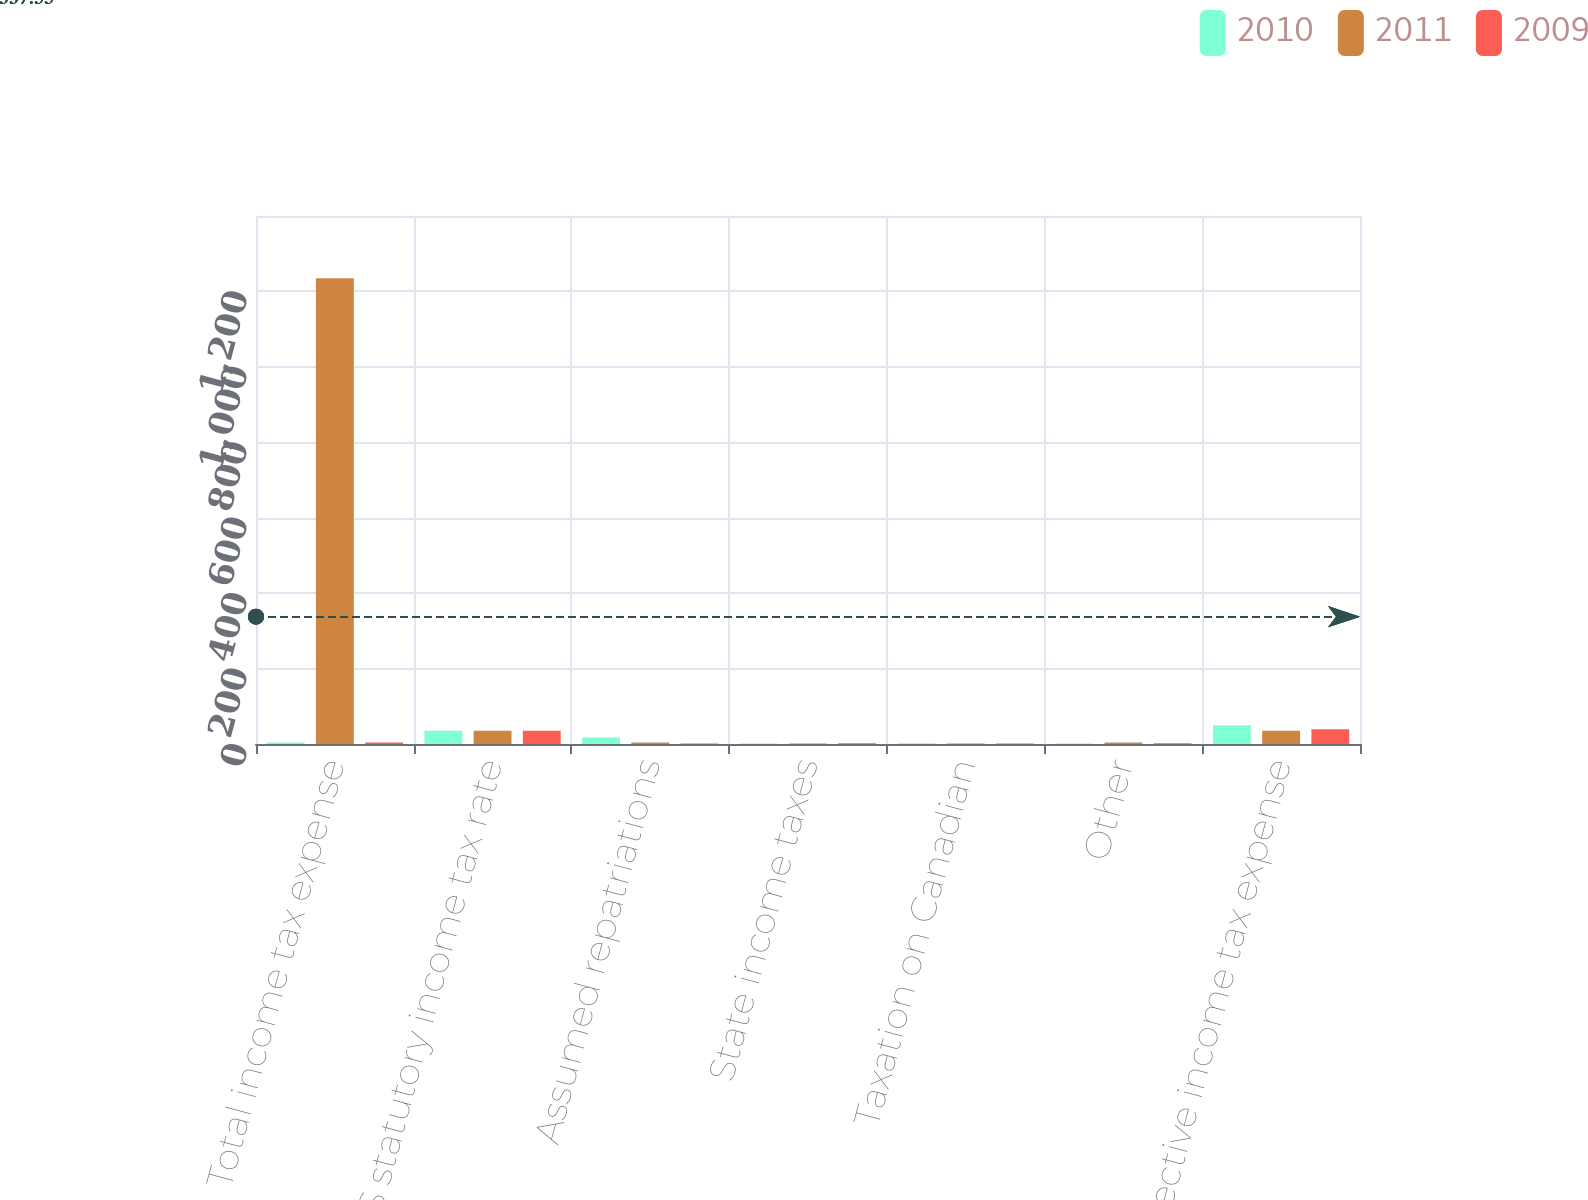<chart> <loc_0><loc_0><loc_500><loc_500><stacked_bar_chart><ecel><fcel>Total income tax expense<fcel>US statutory income tax rate<fcel>Assumed repatriations<fcel>State income taxes<fcel>Taxation on Canadian<fcel>Other<fcel>Effective income tax expense<nl><fcel>2010<fcel>4<fcel>35<fcel>17<fcel>1<fcel>2<fcel>1<fcel>50<nl><fcel>2011<fcel>1235<fcel>35<fcel>4<fcel>1<fcel>1<fcel>4<fcel>35<nl><fcel>2009<fcel>4<fcel>35<fcel>1<fcel>2<fcel>1<fcel>2<fcel>39<nl></chart> 